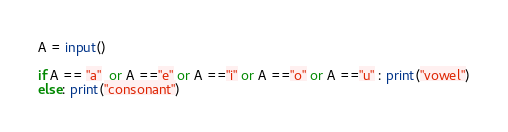<code> <loc_0><loc_0><loc_500><loc_500><_Python_>A = input()

if A == "a"  or A =="e" or A =="i" or A =="o" or A =="u" : print("vowel")
else: print("consonant")
</code> 